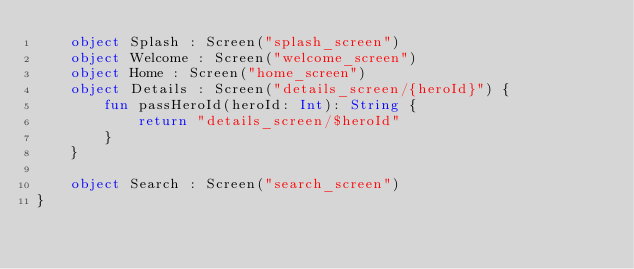Convert code to text. <code><loc_0><loc_0><loc_500><loc_500><_Kotlin_>    object Splash : Screen("splash_screen")
    object Welcome : Screen("welcome_screen")
    object Home : Screen("home_screen")
    object Details : Screen("details_screen/{heroId}") {
        fun passHeroId(heroId: Int): String {
            return "details_screen/$heroId"
        }
    }

    object Search : Screen("search_screen")
}
</code> 